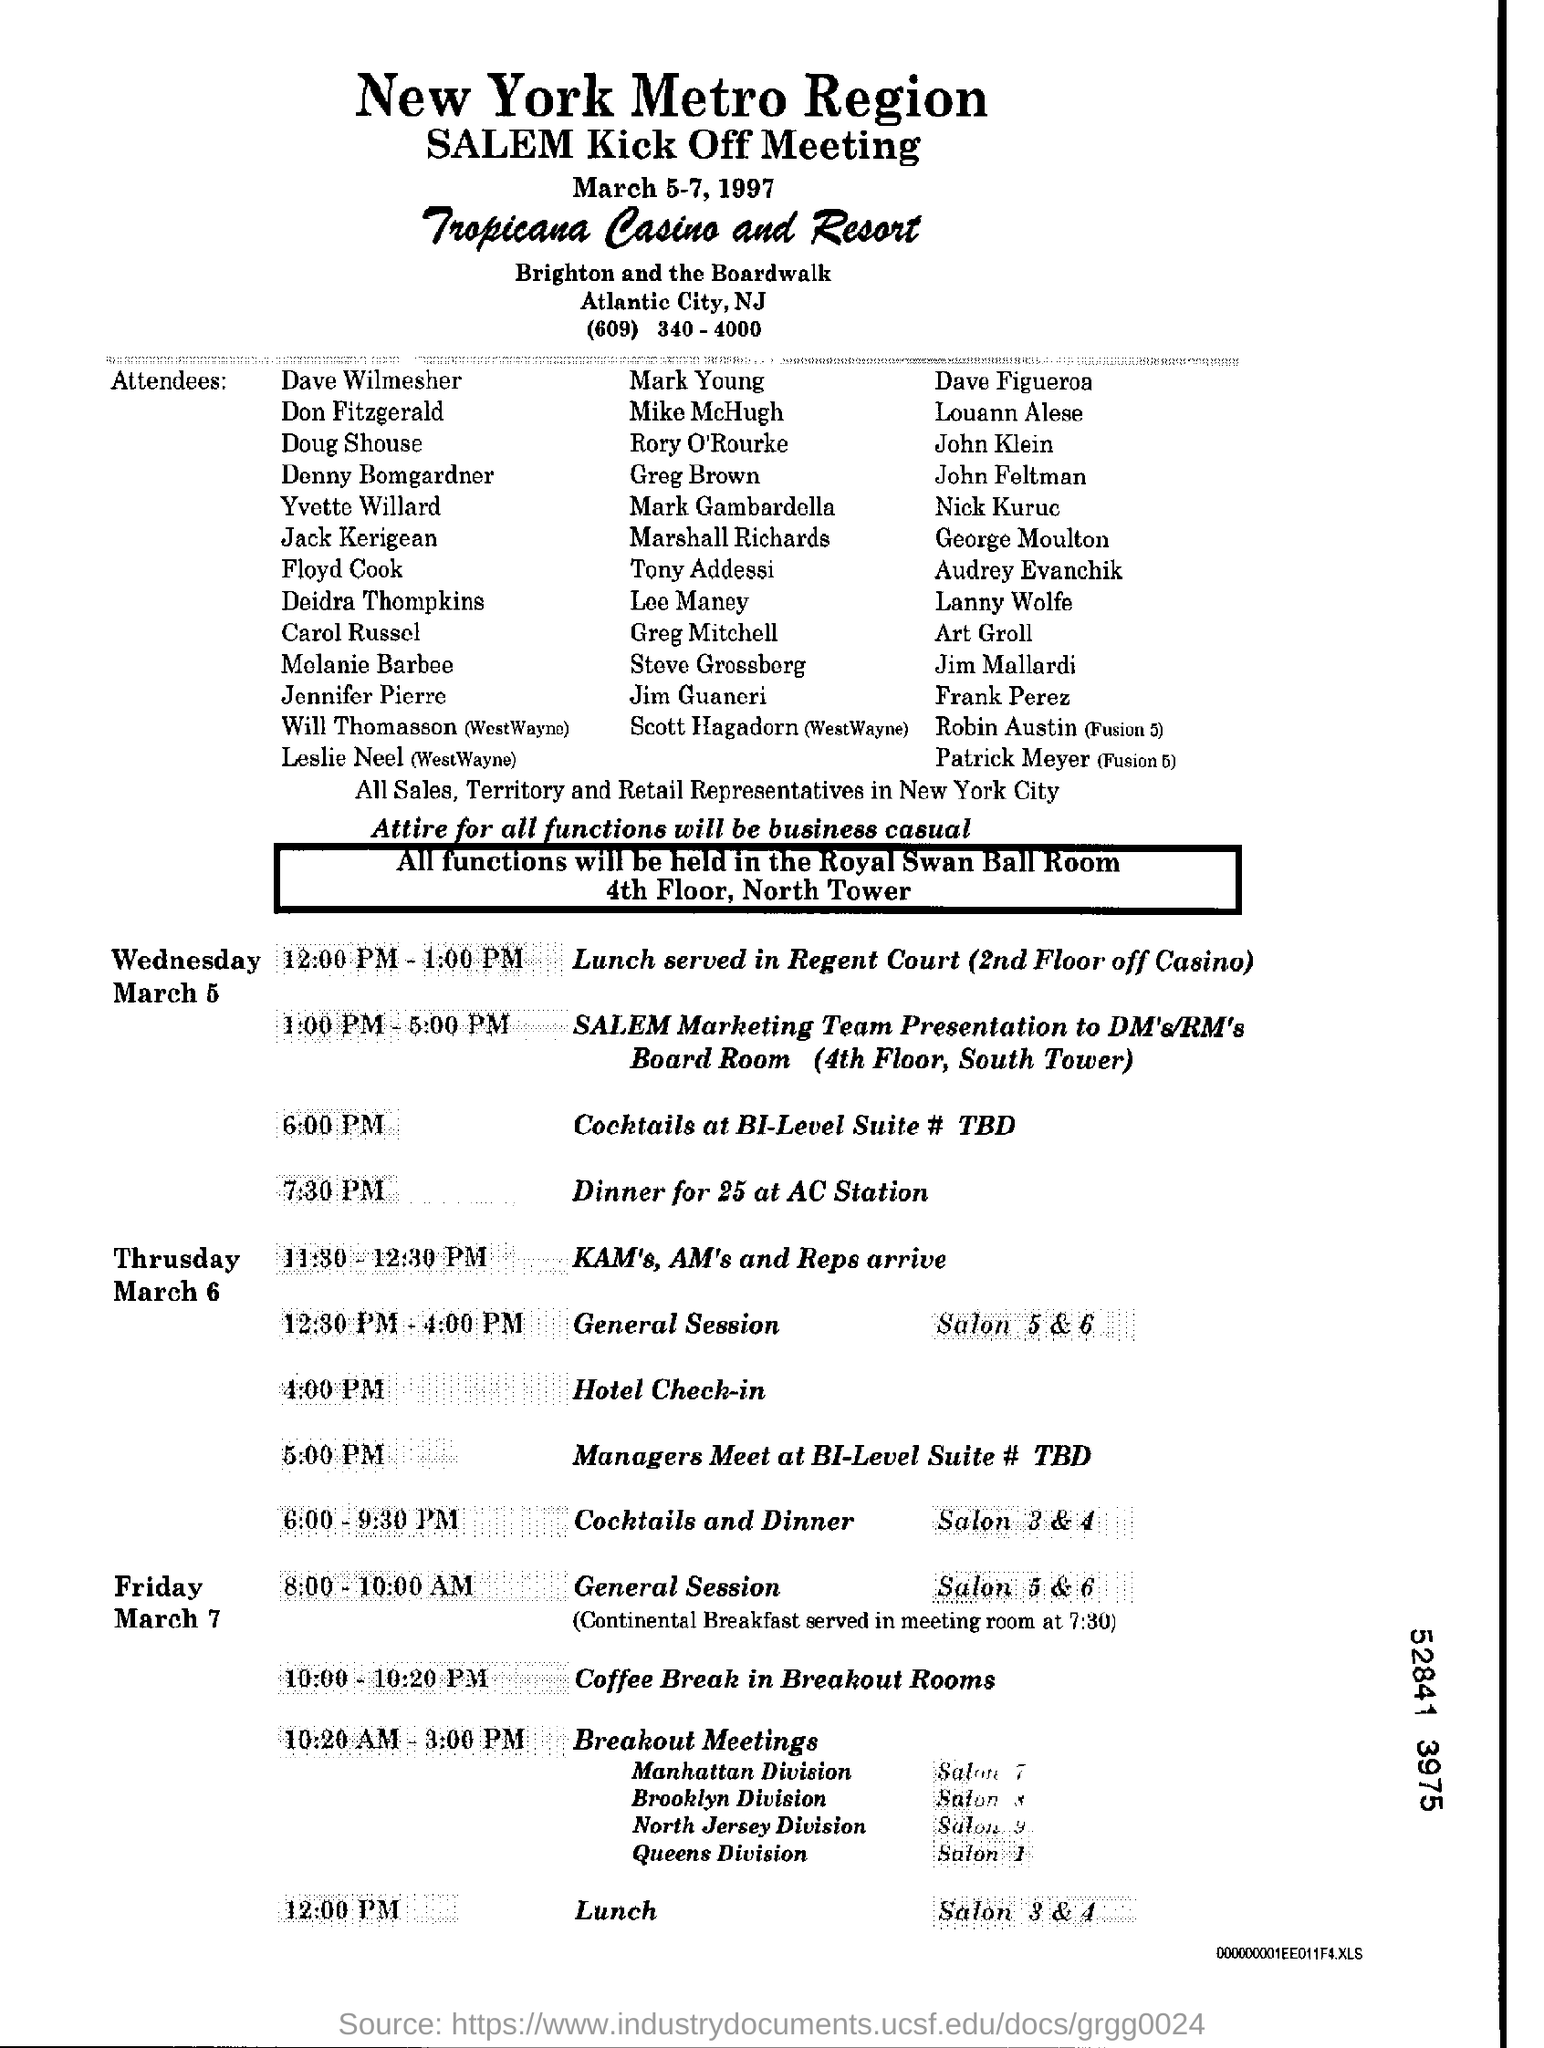What are the details provided for the evening events on Wednesday? The evening events on Wednesday include 'Cocktails at BI-Level Suite' scheduled for 6:00 PM to 9:30 PM. This is followed by 'Dinner for 25 at AC Station' which begins at 7:30 PM, providing an opportunity for attendees to socialize and network. 